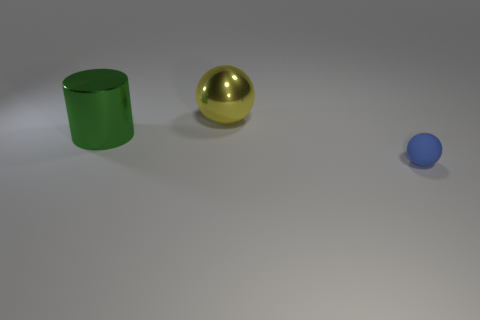There is a ball that is made of the same material as the cylinder; what color is it?
Offer a terse response. Yellow. Is the shape of the yellow thing the same as the object in front of the shiny cylinder?
Provide a succinct answer. Yes. There is a green cylinder that is the same size as the yellow thing; what is it made of?
Offer a very short reply. Metal. Is there a tiny thing that has the same color as the cylinder?
Ensure brevity in your answer.  No. The thing that is both on the right side of the large green object and behind the tiny object has what shape?
Provide a succinct answer. Sphere. How many cylinders have the same material as the small thing?
Provide a short and direct response. 0. Is the number of green things behind the yellow object less than the number of tiny blue matte spheres that are left of the tiny object?
Keep it short and to the point. No. What is the material of the sphere that is behind the sphere in front of the metallic object that is to the left of the large yellow shiny object?
Your answer should be compact. Metal. There is a thing that is on the right side of the big metallic cylinder and in front of the big yellow shiny object; what size is it?
Offer a very short reply. Small. How many cylinders are shiny things or green things?
Ensure brevity in your answer.  1. 